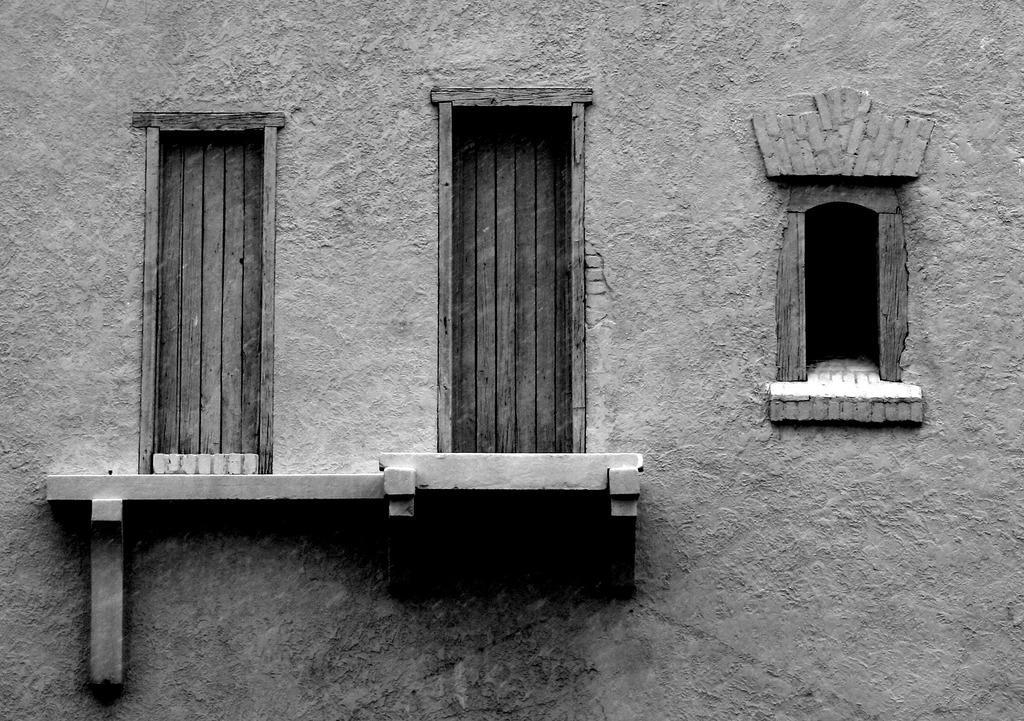Describe this image in one or two sentences. This picture is clicked outside. In the center we can see the building and we can see the windows and a shelf. 